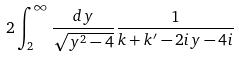<formula> <loc_0><loc_0><loc_500><loc_500>2 \int _ { 2 } ^ { \infty } \frac { d y } { \sqrt { y ^ { 2 } - 4 } } \frac { 1 } { k + k ^ { \prime } - 2 i y - 4 i }</formula> 